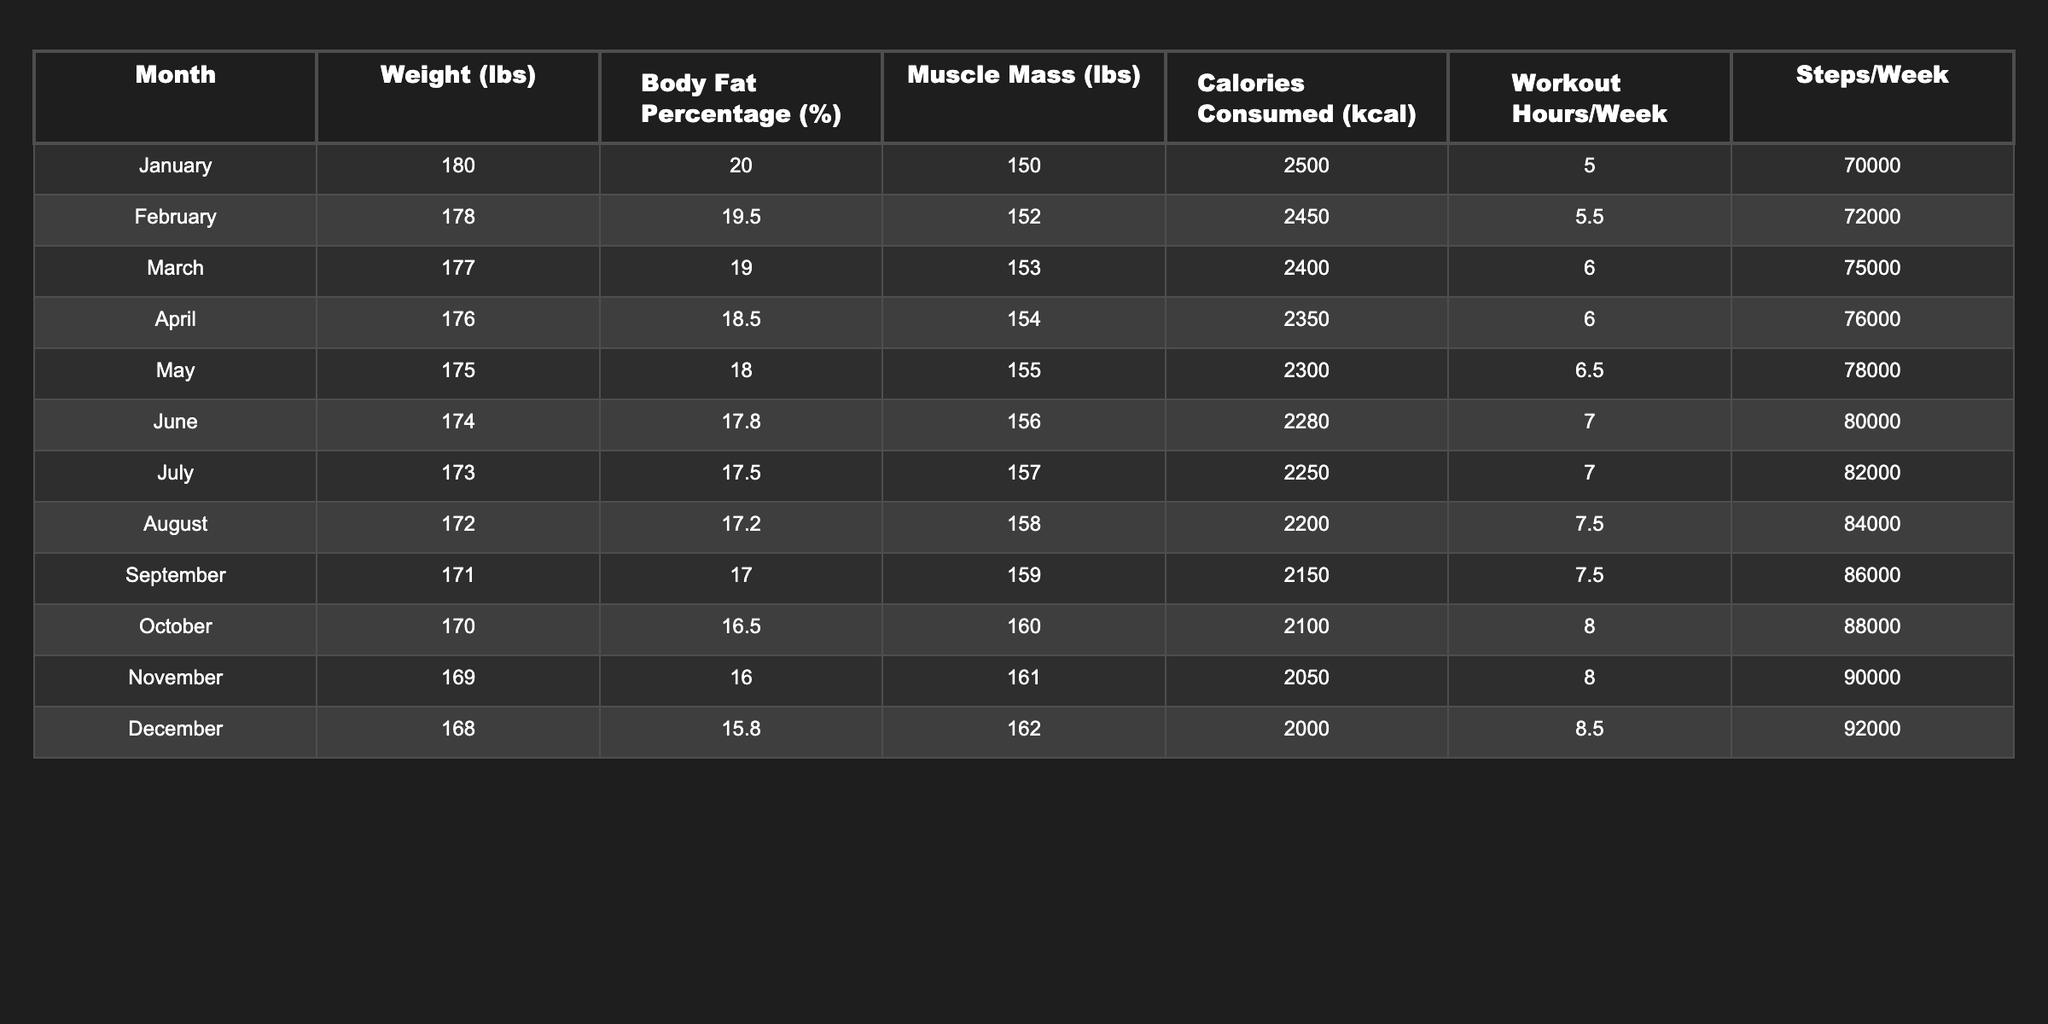What was Eric's weight in March? According to the table, the weight in March is explicitly given as 177 lbs.
Answer: 177 lbs What is the body fat percentage in June? The body fat percentage for June is listed in the table as 17.8%.
Answer: 17.8% In which month did Eric consume the most calories, and how many calories did he consume? By examining the table, the highest calories consumed is 2500 kcal in January.
Answer: January; 2500 kcal What is the average number of workout hours per week over the year? To find the average, sum up all the workout hours: 5 + 5.5 + 6 + 6 + 6.5 + 7 + 7 + 7.5 + 7.5 + 8 + 8 + 8.5 = 84. The average over 12 months is 84/12 = 7.
Answer: 7 hours/week Did Eric ever have a body fat percentage above 20% during the year? Looking through the table, the body fat percentage was 20% in January, which indicates he did exceed that threshold.
Answer: Yes What is the total weight loss from January to December? The weight in January is 180 lbs and in December is 168 lbs. The total weight loss is 180 - 168 = 12 lbs.
Answer: 12 lbs How many muscle mass pounds did Eric gain from February to May? The muscle mass in February is 152 lbs, and in May, it is 155 lbs. To find the gain, subtract February's weight from May's: 155 - 152 = 3 lbs gained.
Answer: 3 lbs What was Eric’s average caloric intake over the entire year? The total calories consumed are the sum: 2500 + 2450 + 2400 + 2350 + 2300 + 2280 + 2250 + 2200 + 2150 + 2100 + 2050 + 2000 = 26780. The average is then 26780/12 = 2231.67, approximately 2232 kcal.
Answer: 2232 kcal In which month did Eric step the most, and how many steps did he take? The maximum steps recorded in a week are in December with 92000 steps.
Answer: December; 92000 steps Was there a month when Eric had a muscle mass of exactly 156 lbs? The table indicates that Eric’s muscle mass was 156 lbs in June.
Answer: Yes 